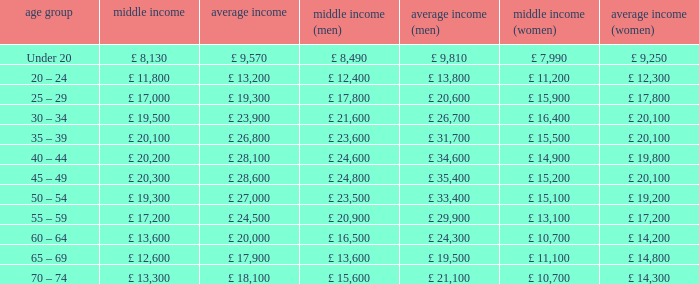Name the median income for age band being under 20 £ 8,130. 